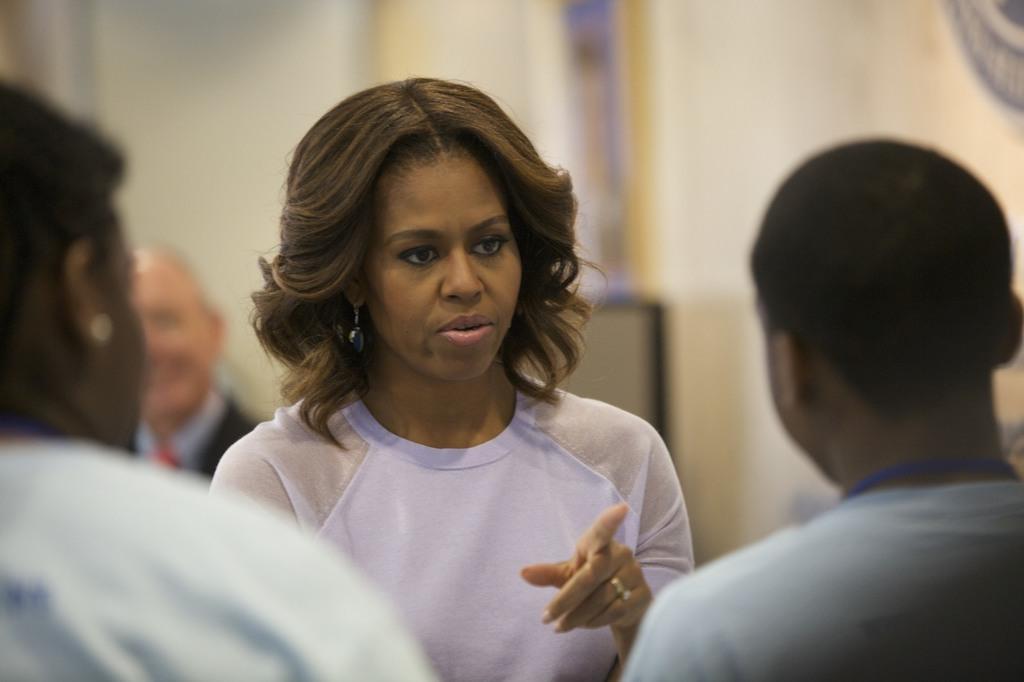How would you summarize this image in a sentence or two? In this image I can see in the middle a woman is speaking, she wore white color top. There are two persons on either side of this image. 